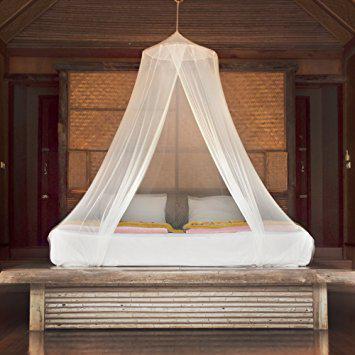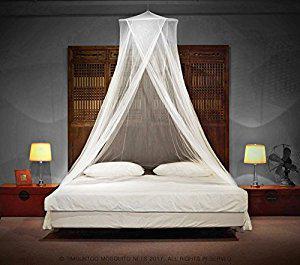The first image is the image on the left, the second image is the image on the right. Analyze the images presented: Is the assertion "Beds are draped in a gauzy material that hangs from a central point in the ceiling over each bed." valid? Answer yes or no. Yes. 